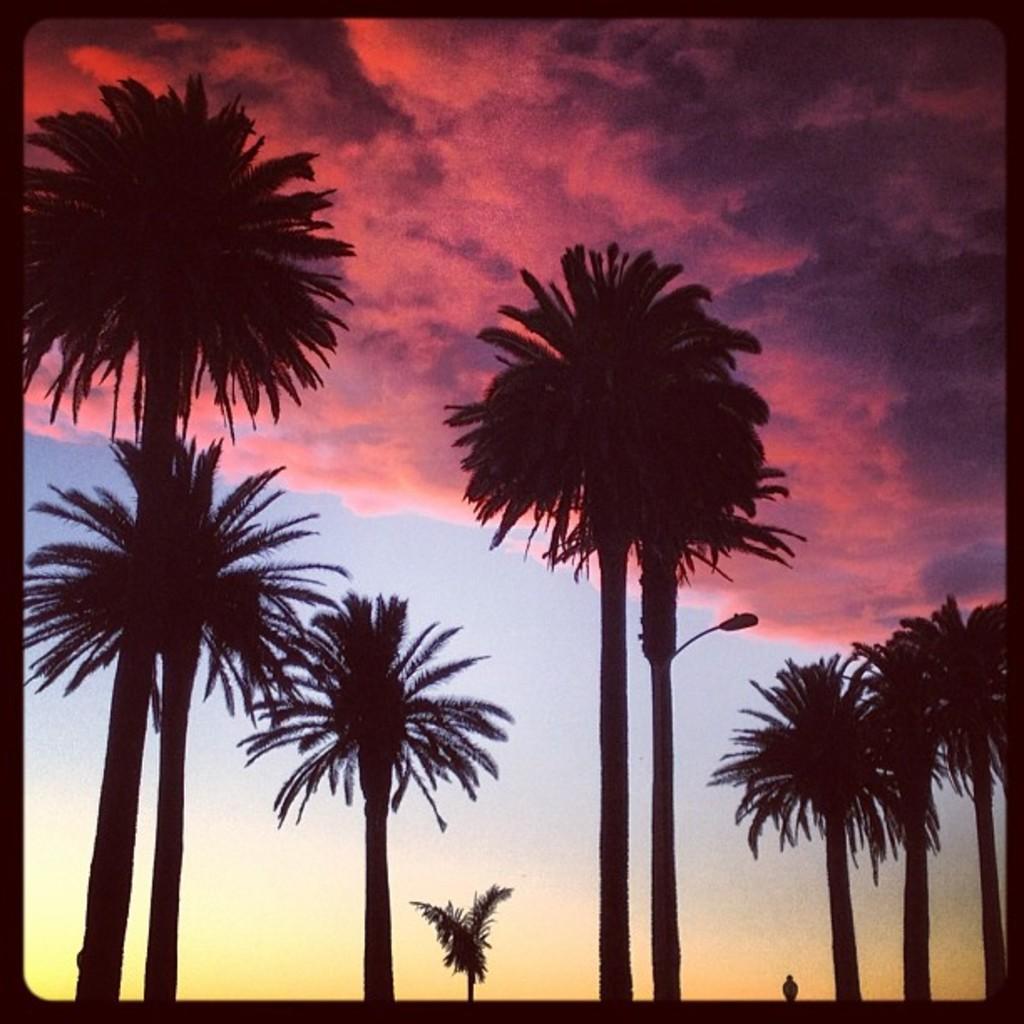Can you describe this image briefly? This image is an edited image. This image is taken outdoors. At the top of the image there is the sky with clouds. In the middle of the image there are a few trees and there is a street light. At the bottom of the image there is a person standing on the ground. 